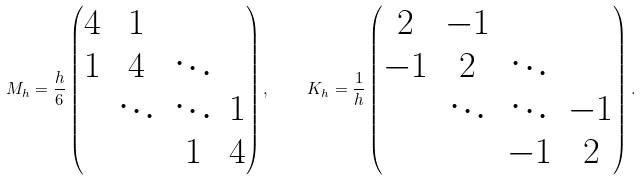Convert formula to latex. <formula><loc_0><loc_0><loc_500><loc_500>M _ { h } = \frac { h } { 6 } \begin{pmatrix} 4 & 1 & & \\ 1 & 4 & \ddots & \\ & \ddots & \ddots & 1 \\ & & 1 & 4 \end{pmatrix} , \quad K _ { h } = \frac { 1 } { h } \begin{pmatrix} 2 & - 1 & & \\ - 1 & 2 & \ddots & \\ & \ddots & \ddots & - 1 \\ & & - 1 & 2 \end{pmatrix} .</formula> 